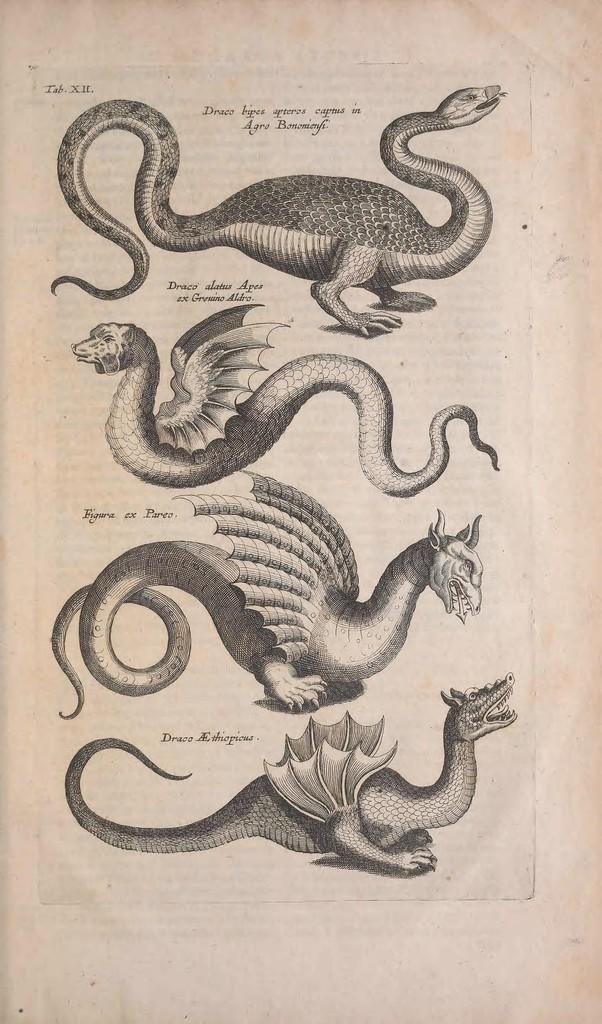In one or two sentences, can you explain what this image depicts? In this image we can see a drawing. In the image we can see four animals and some text on it. 